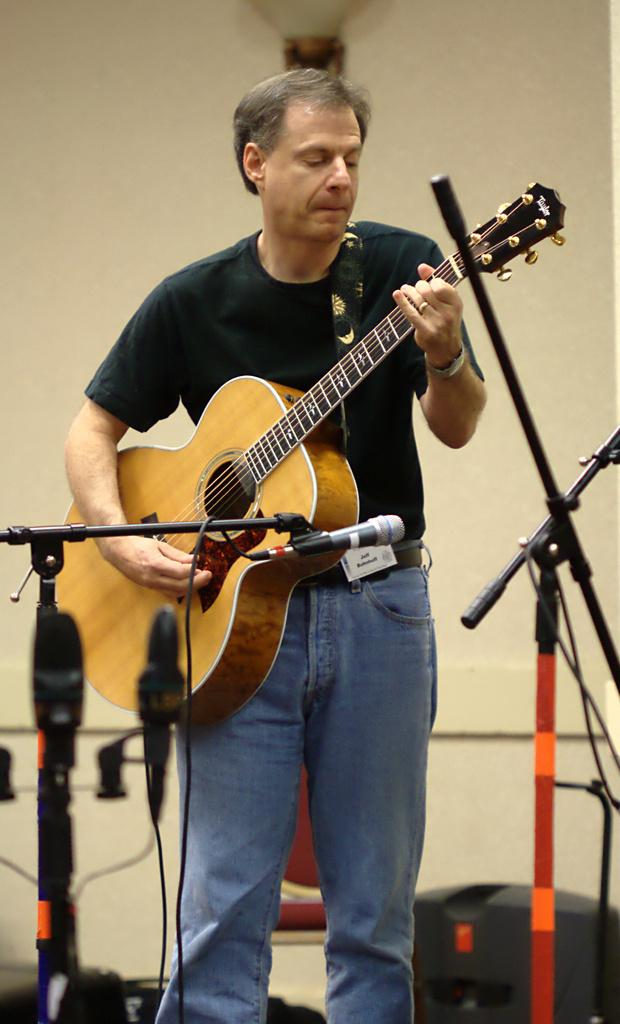What is the person in the image doing? The person is playing the guitar. What is the person wearing in the image? The person is wearing a black shirt and blue jeans. What object is the person holding in the image? The person is holding a guitar. What other object is present in the image? There is a microphone in the image. What type of yam is being used as a sound amplifier for the guitar in the image? There is no yam present in the image, and it is not being used as a sound amplifier for the guitar. 